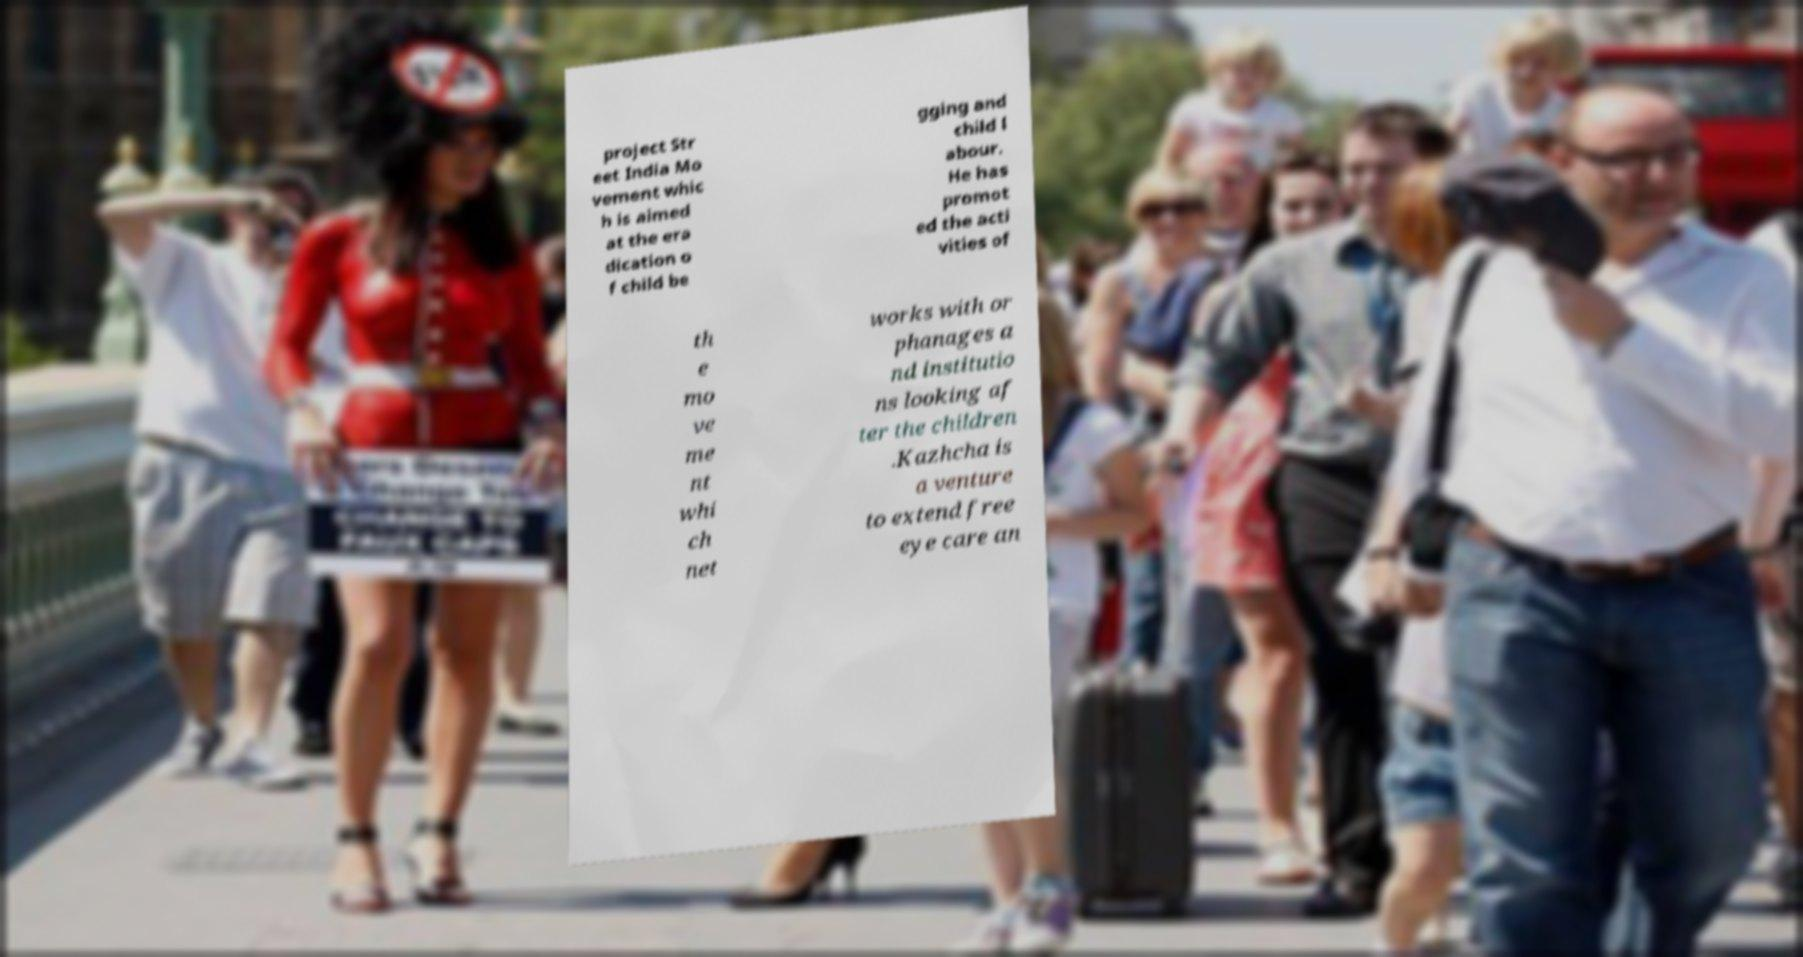For documentation purposes, I need the text within this image transcribed. Could you provide that? project Str eet India Mo vement whic h is aimed at the era dication o f child be gging and child l abour. He has promot ed the acti vities of th e mo ve me nt whi ch net works with or phanages a nd institutio ns looking af ter the children .Kazhcha is a venture to extend free eye care an 